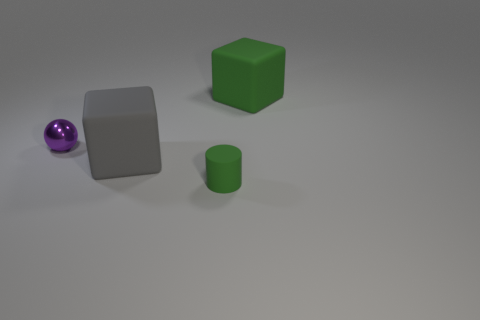Add 1 big purple matte balls. How many objects exist? 5 Subtract all cylinders. How many objects are left? 3 Add 2 big cyan shiny cubes. How many big cyan shiny cubes exist? 2 Subtract 0 purple cylinders. How many objects are left? 4 Subtract all gray shiny cylinders. Subtract all shiny balls. How many objects are left? 3 Add 2 rubber cubes. How many rubber cubes are left? 4 